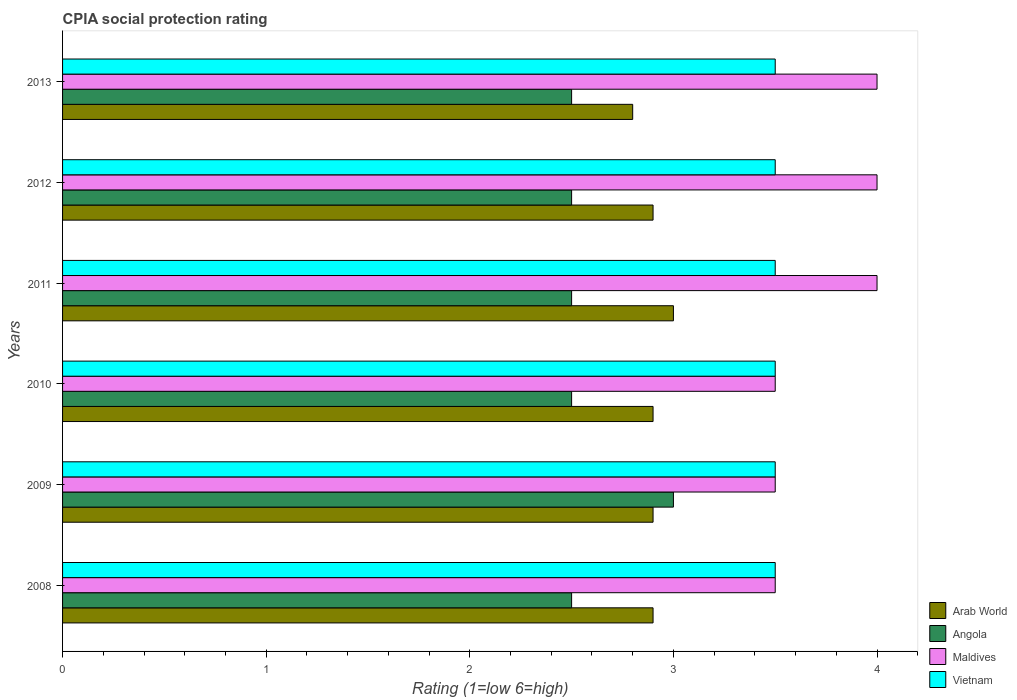How many different coloured bars are there?
Ensure brevity in your answer.  4. How many groups of bars are there?
Keep it short and to the point. 6. How many bars are there on the 2nd tick from the top?
Your response must be concise. 4. How many bars are there on the 5th tick from the bottom?
Keep it short and to the point. 4. What is the label of the 3rd group of bars from the top?
Provide a short and direct response. 2011. In how many cases, is the number of bars for a given year not equal to the number of legend labels?
Your answer should be very brief. 0. In which year was the CPIA rating in Vietnam minimum?
Keep it short and to the point. 2008. What is the total CPIA rating in Angola in the graph?
Provide a short and direct response. 15.5. What is the average CPIA rating in Maldives per year?
Keep it short and to the point. 3.75. What is the ratio of the CPIA rating in Arab World in 2010 to that in 2013?
Provide a short and direct response. 1.04. What is the difference between the highest and the second highest CPIA rating in Vietnam?
Offer a terse response. 0. Is it the case that in every year, the sum of the CPIA rating in Vietnam and CPIA rating in Angola is greater than the sum of CPIA rating in Maldives and CPIA rating in Arab World?
Provide a succinct answer. Yes. What does the 1st bar from the top in 2011 represents?
Offer a very short reply. Vietnam. What does the 2nd bar from the bottom in 2013 represents?
Your answer should be very brief. Angola. How many bars are there?
Ensure brevity in your answer.  24. Are all the bars in the graph horizontal?
Offer a very short reply. Yes. What is the difference between two consecutive major ticks on the X-axis?
Your answer should be compact. 1. Are the values on the major ticks of X-axis written in scientific E-notation?
Your answer should be compact. No. Does the graph contain any zero values?
Provide a succinct answer. No. Does the graph contain grids?
Provide a succinct answer. No. What is the title of the graph?
Your response must be concise. CPIA social protection rating. Does "European Union" appear as one of the legend labels in the graph?
Offer a very short reply. No. What is the label or title of the X-axis?
Your response must be concise. Rating (1=low 6=high). What is the Rating (1=low 6=high) in Angola in 2008?
Offer a very short reply. 2.5. What is the Rating (1=low 6=high) in Vietnam in 2008?
Give a very brief answer. 3.5. What is the Rating (1=low 6=high) of Arab World in 2010?
Offer a terse response. 2.9. What is the Rating (1=low 6=high) in Maldives in 2010?
Offer a very short reply. 3.5. What is the Rating (1=low 6=high) of Vietnam in 2010?
Your response must be concise. 3.5. What is the Rating (1=low 6=high) of Angola in 2011?
Offer a terse response. 2.5. What is the Rating (1=low 6=high) of Maldives in 2011?
Offer a very short reply. 4. What is the Rating (1=low 6=high) in Vietnam in 2011?
Offer a terse response. 3.5. What is the Rating (1=low 6=high) in Arab World in 2012?
Provide a succinct answer. 2.9. What is the Rating (1=low 6=high) in Angola in 2012?
Offer a very short reply. 2.5. What is the Rating (1=low 6=high) of Arab World in 2013?
Offer a terse response. 2.8. What is the Rating (1=low 6=high) of Maldives in 2013?
Provide a succinct answer. 4. Across all years, what is the maximum Rating (1=low 6=high) of Arab World?
Offer a very short reply. 3. Across all years, what is the maximum Rating (1=low 6=high) of Angola?
Your response must be concise. 3. Across all years, what is the maximum Rating (1=low 6=high) of Maldives?
Your answer should be compact. 4. Across all years, what is the maximum Rating (1=low 6=high) in Vietnam?
Provide a succinct answer. 3.5. Across all years, what is the minimum Rating (1=low 6=high) in Angola?
Provide a short and direct response. 2.5. What is the total Rating (1=low 6=high) of Arab World in the graph?
Provide a succinct answer. 17.4. What is the total Rating (1=low 6=high) in Maldives in the graph?
Offer a terse response. 22.5. What is the total Rating (1=low 6=high) in Vietnam in the graph?
Keep it short and to the point. 21. What is the difference between the Rating (1=low 6=high) of Arab World in 2008 and that in 2009?
Your answer should be very brief. 0. What is the difference between the Rating (1=low 6=high) of Angola in 2008 and that in 2009?
Ensure brevity in your answer.  -0.5. What is the difference between the Rating (1=low 6=high) of Vietnam in 2008 and that in 2009?
Ensure brevity in your answer.  0. What is the difference between the Rating (1=low 6=high) of Angola in 2008 and that in 2010?
Provide a succinct answer. 0. What is the difference between the Rating (1=low 6=high) in Arab World in 2008 and that in 2011?
Your answer should be compact. -0.1. What is the difference between the Rating (1=low 6=high) in Maldives in 2008 and that in 2011?
Ensure brevity in your answer.  -0.5. What is the difference between the Rating (1=low 6=high) of Arab World in 2008 and that in 2012?
Your answer should be compact. 0. What is the difference between the Rating (1=low 6=high) in Angola in 2008 and that in 2012?
Your answer should be very brief. 0. What is the difference between the Rating (1=low 6=high) of Maldives in 2008 and that in 2012?
Provide a succinct answer. -0.5. What is the difference between the Rating (1=low 6=high) of Vietnam in 2008 and that in 2012?
Ensure brevity in your answer.  0. What is the difference between the Rating (1=low 6=high) of Arab World in 2008 and that in 2013?
Provide a succinct answer. 0.1. What is the difference between the Rating (1=low 6=high) of Angola in 2008 and that in 2013?
Keep it short and to the point. 0. What is the difference between the Rating (1=low 6=high) of Maldives in 2008 and that in 2013?
Give a very brief answer. -0.5. What is the difference between the Rating (1=low 6=high) in Arab World in 2009 and that in 2010?
Offer a terse response. 0. What is the difference between the Rating (1=low 6=high) of Vietnam in 2009 and that in 2010?
Offer a terse response. 0. What is the difference between the Rating (1=low 6=high) in Angola in 2009 and that in 2011?
Offer a terse response. 0.5. What is the difference between the Rating (1=low 6=high) in Maldives in 2009 and that in 2011?
Your answer should be compact. -0.5. What is the difference between the Rating (1=low 6=high) of Vietnam in 2009 and that in 2012?
Your response must be concise. 0. What is the difference between the Rating (1=low 6=high) in Arab World in 2009 and that in 2013?
Keep it short and to the point. 0.1. What is the difference between the Rating (1=low 6=high) in Maldives in 2009 and that in 2013?
Your response must be concise. -0.5. What is the difference between the Rating (1=low 6=high) of Vietnam in 2009 and that in 2013?
Provide a short and direct response. 0. What is the difference between the Rating (1=low 6=high) in Arab World in 2010 and that in 2012?
Make the answer very short. 0. What is the difference between the Rating (1=low 6=high) in Angola in 2010 and that in 2012?
Provide a succinct answer. 0. What is the difference between the Rating (1=low 6=high) in Maldives in 2010 and that in 2012?
Provide a succinct answer. -0.5. What is the difference between the Rating (1=low 6=high) of Maldives in 2010 and that in 2013?
Your answer should be very brief. -0.5. What is the difference between the Rating (1=low 6=high) in Maldives in 2011 and that in 2012?
Keep it short and to the point. 0. What is the difference between the Rating (1=low 6=high) of Arab World in 2011 and that in 2013?
Your response must be concise. 0.2. What is the difference between the Rating (1=low 6=high) of Arab World in 2012 and that in 2013?
Provide a short and direct response. 0.1. What is the difference between the Rating (1=low 6=high) of Angola in 2012 and that in 2013?
Make the answer very short. 0. What is the difference between the Rating (1=low 6=high) in Arab World in 2008 and the Rating (1=low 6=high) in Maldives in 2009?
Provide a succinct answer. -0.6. What is the difference between the Rating (1=low 6=high) in Arab World in 2008 and the Rating (1=low 6=high) in Vietnam in 2009?
Provide a succinct answer. -0.6. What is the difference between the Rating (1=low 6=high) of Angola in 2008 and the Rating (1=low 6=high) of Vietnam in 2009?
Give a very brief answer. -1. What is the difference between the Rating (1=low 6=high) of Maldives in 2008 and the Rating (1=low 6=high) of Vietnam in 2009?
Provide a succinct answer. 0. What is the difference between the Rating (1=low 6=high) in Angola in 2008 and the Rating (1=low 6=high) in Maldives in 2010?
Ensure brevity in your answer.  -1. What is the difference between the Rating (1=low 6=high) of Angola in 2008 and the Rating (1=low 6=high) of Vietnam in 2010?
Give a very brief answer. -1. What is the difference between the Rating (1=low 6=high) in Maldives in 2008 and the Rating (1=low 6=high) in Vietnam in 2010?
Offer a very short reply. 0. What is the difference between the Rating (1=low 6=high) of Angola in 2008 and the Rating (1=low 6=high) of Maldives in 2011?
Offer a terse response. -1.5. What is the difference between the Rating (1=low 6=high) in Angola in 2008 and the Rating (1=low 6=high) in Maldives in 2012?
Your response must be concise. -1.5. What is the difference between the Rating (1=low 6=high) in Arab World in 2008 and the Rating (1=low 6=high) in Maldives in 2013?
Make the answer very short. -1.1. What is the difference between the Rating (1=low 6=high) in Arab World in 2008 and the Rating (1=low 6=high) in Vietnam in 2013?
Offer a terse response. -0.6. What is the difference between the Rating (1=low 6=high) of Maldives in 2008 and the Rating (1=low 6=high) of Vietnam in 2013?
Provide a succinct answer. 0. What is the difference between the Rating (1=low 6=high) in Arab World in 2009 and the Rating (1=low 6=high) in Vietnam in 2010?
Make the answer very short. -0.6. What is the difference between the Rating (1=low 6=high) of Maldives in 2009 and the Rating (1=low 6=high) of Vietnam in 2010?
Offer a very short reply. 0. What is the difference between the Rating (1=low 6=high) in Arab World in 2009 and the Rating (1=low 6=high) in Angola in 2011?
Provide a short and direct response. 0.4. What is the difference between the Rating (1=low 6=high) of Arab World in 2009 and the Rating (1=low 6=high) of Vietnam in 2011?
Offer a very short reply. -0.6. What is the difference between the Rating (1=low 6=high) of Angola in 2009 and the Rating (1=low 6=high) of Maldives in 2011?
Your answer should be compact. -1. What is the difference between the Rating (1=low 6=high) in Angola in 2009 and the Rating (1=low 6=high) in Vietnam in 2011?
Keep it short and to the point. -0.5. What is the difference between the Rating (1=low 6=high) of Maldives in 2009 and the Rating (1=low 6=high) of Vietnam in 2011?
Offer a terse response. 0. What is the difference between the Rating (1=low 6=high) in Arab World in 2009 and the Rating (1=low 6=high) in Angola in 2012?
Give a very brief answer. 0.4. What is the difference between the Rating (1=low 6=high) in Angola in 2009 and the Rating (1=low 6=high) in Vietnam in 2012?
Your response must be concise. -0.5. What is the difference between the Rating (1=low 6=high) in Arab World in 2009 and the Rating (1=low 6=high) in Vietnam in 2013?
Your answer should be compact. -0.6. What is the difference between the Rating (1=low 6=high) in Angola in 2009 and the Rating (1=low 6=high) in Vietnam in 2013?
Your response must be concise. -0.5. What is the difference between the Rating (1=low 6=high) of Maldives in 2009 and the Rating (1=low 6=high) of Vietnam in 2013?
Offer a very short reply. 0. What is the difference between the Rating (1=low 6=high) in Arab World in 2010 and the Rating (1=low 6=high) in Maldives in 2011?
Ensure brevity in your answer.  -1.1. What is the difference between the Rating (1=low 6=high) in Arab World in 2010 and the Rating (1=low 6=high) in Vietnam in 2011?
Make the answer very short. -0.6. What is the difference between the Rating (1=low 6=high) of Arab World in 2010 and the Rating (1=low 6=high) of Vietnam in 2012?
Keep it short and to the point. -0.6. What is the difference between the Rating (1=low 6=high) of Angola in 2010 and the Rating (1=low 6=high) of Maldives in 2012?
Your answer should be very brief. -1.5. What is the difference between the Rating (1=low 6=high) of Angola in 2010 and the Rating (1=low 6=high) of Vietnam in 2012?
Your answer should be compact. -1. What is the difference between the Rating (1=low 6=high) of Maldives in 2010 and the Rating (1=low 6=high) of Vietnam in 2012?
Provide a short and direct response. 0. What is the difference between the Rating (1=low 6=high) of Arab World in 2010 and the Rating (1=low 6=high) of Angola in 2013?
Make the answer very short. 0.4. What is the difference between the Rating (1=low 6=high) in Angola in 2010 and the Rating (1=low 6=high) in Maldives in 2013?
Make the answer very short. -1.5. What is the difference between the Rating (1=low 6=high) of Angola in 2010 and the Rating (1=low 6=high) of Vietnam in 2013?
Keep it short and to the point. -1. What is the difference between the Rating (1=low 6=high) in Maldives in 2010 and the Rating (1=low 6=high) in Vietnam in 2013?
Offer a terse response. 0. What is the difference between the Rating (1=low 6=high) in Arab World in 2011 and the Rating (1=low 6=high) in Angola in 2012?
Provide a succinct answer. 0.5. What is the difference between the Rating (1=low 6=high) of Angola in 2011 and the Rating (1=low 6=high) of Maldives in 2012?
Provide a short and direct response. -1.5. What is the difference between the Rating (1=low 6=high) in Arab World in 2011 and the Rating (1=low 6=high) in Maldives in 2013?
Offer a terse response. -1. What is the difference between the Rating (1=low 6=high) of Arab World in 2011 and the Rating (1=low 6=high) of Vietnam in 2013?
Your answer should be very brief. -0.5. What is the difference between the Rating (1=low 6=high) in Angola in 2011 and the Rating (1=low 6=high) in Maldives in 2013?
Your response must be concise. -1.5. What is the difference between the Rating (1=low 6=high) in Angola in 2011 and the Rating (1=low 6=high) in Vietnam in 2013?
Ensure brevity in your answer.  -1. What is the difference between the Rating (1=low 6=high) of Arab World in 2012 and the Rating (1=low 6=high) of Angola in 2013?
Your answer should be compact. 0.4. What is the difference between the Rating (1=low 6=high) in Arab World in 2012 and the Rating (1=low 6=high) in Vietnam in 2013?
Give a very brief answer. -0.6. What is the difference between the Rating (1=low 6=high) in Maldives in 2012 and the Rating (1=low 6=high) in Vietnam in 2013?
Your answer should be compact. 0.5. What is the average Rating (1=low 6=high) of Arab World per year?
Your response must be concise. 2.9. What is the average Rating (1=low 6=high) in Angola per year?
Offer a terse response. 2.58. What is the average Rating (1=low 6=high) in Maldives per year?
Keep it short and to the point. 3.75. What is the average Rating (1=low 6=high) in Vietnam per year?
Ensure brevity in your answer.  3.5. In the year 2008, what is the difference between the Rating (1=low 6=high) in Arab World and Rating (1=low 6=high) in Maldives?
Your response must be concise. -0.6. In the year 2008, what is the difference between the Rating (1=low 6=high) in Arab World and Rating (1=low 6=high) in Vietnam?
Give a very brief answer. -0.6. In the year 2009, what is the difference between the Rating (1=low 6=high) in Arab World and Rating (1=low 6=high) in Angola?
Offer a terse response. -0.1. In the year 2009, what is the difference between the Rating (1=low 6=high) of Angola and Rating (1=low 6=high) of Maldives?
Make the answer very short. -0.5. In the year 2009, what is the difference between the Rating (1=low 6=high) in Maldives and Rating (1=low 6=high) in Vietnam?
Offer a very short reply. 0. In the year 2010, what is the difference between the Rating (1=low 6=high) in Arab World and Rating (1=low 6=high) in Angola?
Give a very brief answer. 0.4. In the year 2010, what is the difference between the Rating (1=low 6=high) in Arab World and Rating (1=low 6=high) in Maldives?
Your answer should be compact. -0.6. In the year 2010, what is the difference between the Rating (1=low 6=high) in Arab World and Rating (1=low 6=high) in Vietnam?
Your answer should be compact. -0.6. In the year 2011, what is the difference between the Rating (1=low 6=high) of Arab World and Rating (1=low 6=high) of Angola?
Your answer should be very brief. 0.5. In the year 2011, what is the difference between the Rating (1=low 6=high) in Arab World and Rating (1=low 6=high) in Maldives?
Make the answer very short. -1. In the year 2011, what is the difference between the Rating (1=low 6=high) of Arab World and Rating (1=low 6=high) of Vietnam?
Make the answer very short. -0.5. In the year 2011, what is the difference between the Rating (1=low 6=high) of Angola and Rating (1=low 6=high) of Maldives?
Keep it short and to the point. -1.5. In the year 2012, what is the difference between the Rating (1=low 6=high) of Arab World and Rating (1=low 6=high) of Maldives?
Offer a very short reply. -1.1. In the year 2012, what is the difference between the Rating (1=low 6=high) of Arab World and Rating (1=low 6=high) of Vietnam?
Provide a short and direct response. -0.6. In the year 2012, what is the difference between the Rating (1=low 6=high) of Angola and Rating (1=low 6=high) of Vietnam?
Provide a short and direct response. -1. In the year 2013, what is the difference between the Rating (1=low 6=high) in Arab World and Rating (1=low 6=high) in Angola?
Ensure brevity in your answer.  0.3. In the year 2013, what is the difference between the Rating (1=low 6=high) in Arab World and Rating (1=low 6=high) in Maldives?
Provide a succinct answer. -1.2. In the year 2013, what is the difference between the Rating (1=low 6=high) of Angola and Rating (1=low 6=high) of Vietnam?
Provide a succinct answer. -1. What is the ratio of the Rating (1=low 6=high) of Angola in 2008 to that in 2009?
Make the answer very short. 0.83. What is the ratio of the Rating (1=low 6=high) of Angola in 2008 to that in 2010?
Your answer should be compact. 1. What is the ratio of the Rating (1=low 6=high) of Maldives in 2008 to that in 2010?
Make the answer very short. 1. What is the ratio of the Rating (1=low 6=high) of Vietnam in 2008 to that in 2010?
Offer a very short reply. 1. What is the ratio of the Rating (1=low 6=high) in Arab World in 2008 to that in 2011?
Provide a succinct answer. 0.97. What is the ratio of the Rating (1=low 6=high) in Arab World in 2008 to that in 2013?
Your answer should be very brief. 1.04. What is the ratio of the Rating (1=low 6=high) in Angola in 2008 to that in 2013?
Make the answer very short. 1. What is the ratio of the Rating (1=low 6=high) in Maldives in 2008 to that in 2013?
Offer a terse response. 0.88. What is the ratio of the Rating (1=low 6=high) of Arab World in 2009 to that in 2010?
Provide a succinct answer. 1. What is the ratio of the Rating (1=low 6=high) in Vietnam in 2009 to that in 2010?
Your answer should be very brief. 1. What is the ratio of the Rating (1=low 6=high) of Arab World in 2009 to that in 2011?
Provide a short and direct response. 0.97. What is the ratio of the Rating (1=low 6=high) in Angola in 2009 to that in 2011?
Your answer should be compact. 1.2. What is the ratio of the Rating (1=low 6=high) of Maldives in 2009 to that in 2011?
Your answer should be compact. 0.88. What is the ratio of the Rating (1=low 6=high) of Vietnam in 2009 to that in 2011?
Your response must be concise. 1. What is the ratio of the Rating (1=low 6=high) in Angola in 2009 to that in 2012?
Offer a very short reply. 1.2. What is the ratio of the Rating (1=low 6=high) in Maldives in 2009 to that in 2012?
Your answer should be very brief. 0.88. What is the ratio of the Rating (1=low 6=high) of Arab World in 2009 to that in 2013?
Ensure brevity in your answer.  1.04. What is the ratio of the Rating (1=low 6=high) of Angola in 2009 to that in 2013?
Your answer should be compact. 1.2. What is the ratio of the Rating (1=low 6=high) in Vietnam in 2009 to that in 2013?
Your answer should be very brief. 1. What is the ratio of the Rating (1=low 6=high) in Arab World in 2010 to that in 2011?
Your response must be concise. 0.97. What is the ratio of the Rating (1=low 6=high) of Vietnam in 2010 to that in 2011?
Your answer should be compact. 1. What is the ratio of the Rating (1=low 6=high) in Arab World in 2010 to that in 2012?
Your response must be concise. 1. What is the ratio of the Rating (1=low 6=high) of Maldives in 2010 to that in 2012?
Your answer should be very brief. 0.88. What is the ratio of the Rating (1=low 6=high) of Vietnam in 2010 to that in 2012?
Make the answer very short. 1. What is the ratio of the Rating (1=low 6=high) of Arab World in 2010 to that in 2013?
Provide a short and direct response. 1.04. What is the ratio of the Rating (1=low 6=high) in Vietnam in 2010 to that in 2013?
Provide a succinct answer. 1. What is the ratio of the Rating (1=low 6=high) of Arab World in 2011 to that in 2012?
Offer a very short reply. 1.03. What is the ratio of the Rating (1=low 6=high) of Angola in 2011 to that in 2012?
Keep it short and to the point. 1. What is the ratio of the Rating (1=low 6=high) of Maldives in 2011 to that in 2012?
Offer a terse response. 1. What is the ratio of the Rating (1=low 6=high) of Arab World in 2011 to that in 2013?
Provide a succinct answer. 1.07. What is the ratio of the Rating (1=low 6=high) of Arab World in 2012 to that in 2013?
Give a very brief answer. 1.04. What is the ratio of the Rating (1=low 6=high) of Angola in 2012 to that in 2013?
Give a very brief answer. 1. What is the ratio of the Rating (1=low 6=high) of Maldives in 2012 to that in 2013?
Make the answer very short. 1. What is the difference between the highest and the second highest Rating (1=low 6=high) in Arab World?
Offer a terse response. 0.1. What is the difference between the highest and the second highest Rating (1=low 6=high) in Angola?
Provide a succinct answer. 0.5. What is the difference between the highest and the second highest Rating (1=low 6=high) of Maldives?
Your answer should be very brief. 0. What is the difference between the highest and the second highest Rating (1=low 6=high) of Vietnam?
Provide a short and direct response. 0. What is the difference between the highest and the lowest Rating (1=low 6=high) in Arab World?
Provide a succinct answer. 0.2. What is the difference between the highest and the lowest Rating (1=low 6=high) of Angola?
Ensure brevity in your answer.  0.5. What is the difference between the highest and the lowest Rating (1=low 6=high) of Maldives?
Your answer should be very brief. 0.5. 